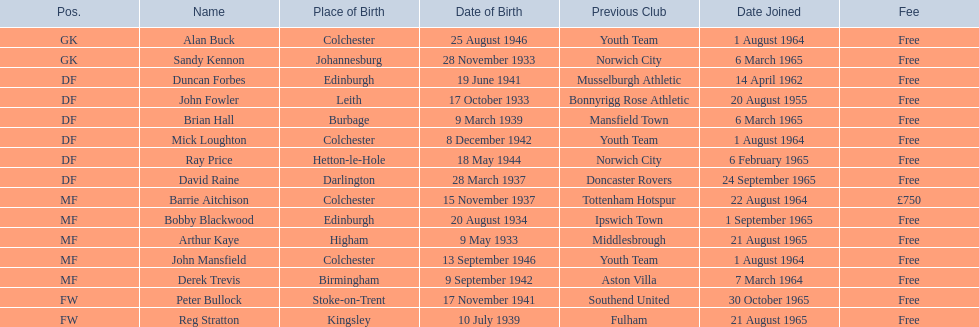Who are all the individuals involved? Alan Buck, Sandy Kennon, Duncan Forbes, John Fowler, Brian Hall, Mick Loughton, Ray Price, David Raine, Barrie Aitchison, Bobby Blackwood, Arthur Kaye, John Mansfield, Derek Trevis, Peter Bullock, Reg Stratton. What dates did these individuals join on? 1 August 1964, 6 March 1965, 14 April 1962, 20 August 1955, 6 March 1965, 1 August 1964, 6 February 1965, 24 September 1965, 22 August 1964, 1 September 1965, 21 August 1965, 1 August 1964, 7 March 1964, 30 October 1965, 21 August 1965. Who is the first individual who joined? John Fowler. What is the date of the first person who joined? 20 August 1955. 